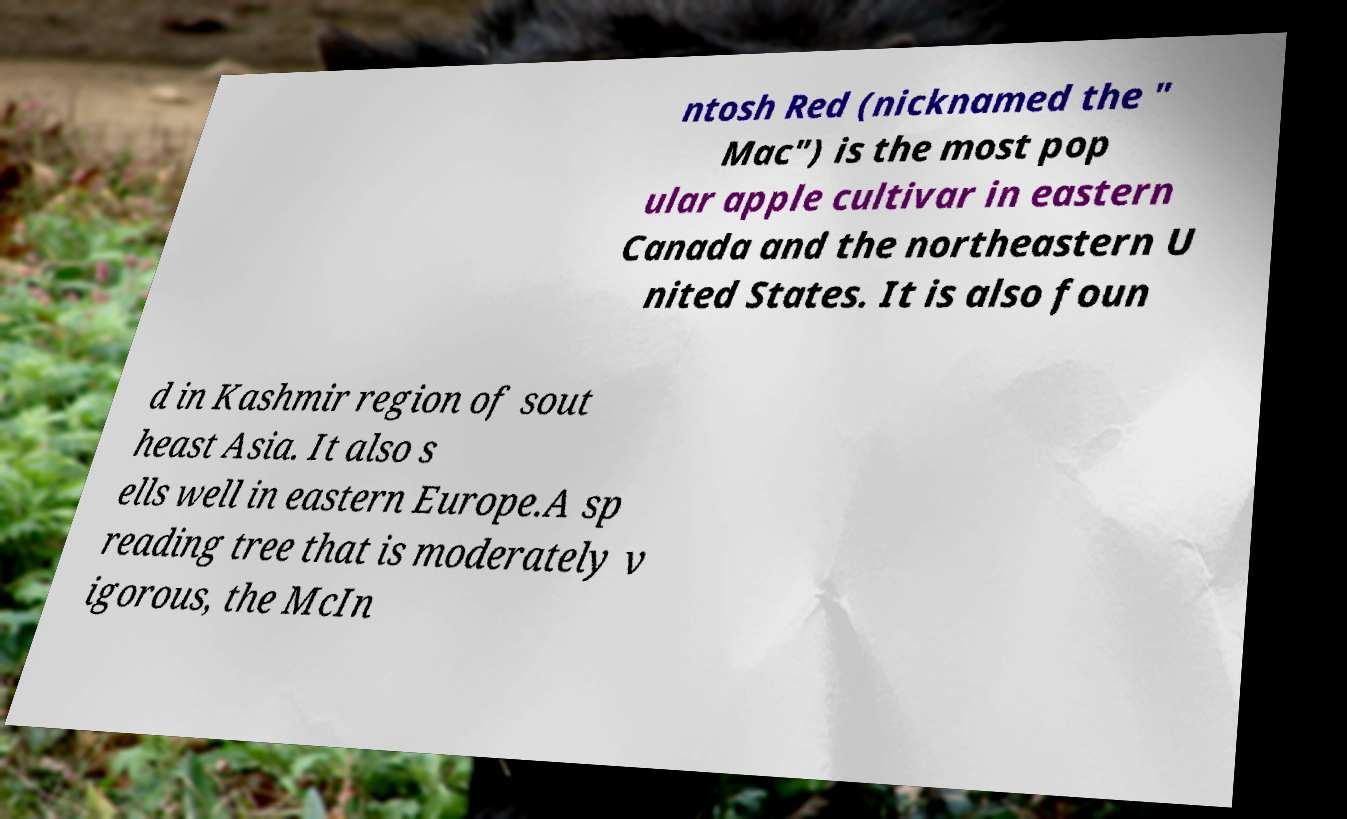What messages or text are displayed in this image? I need them in a readable, typed format. ntosh Red (nicknamed the " Mac") is the most pop ular apple cultivar in eastern Canada and the northeastern U nited States. It is also foun d in Kashmir region of sout heast Asia. It also s ells well in eastern Europe.A sp reading tree that is moderately v igorous, the McIn 